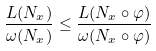Convert formula to latex. <formula><loc_0><loc_0><loc_500><loc_500>\frac { L ( N _ { x } ) } { \omega ( N _ { x } ) } \leq \frac { L ( N _ { x } \circ \varphi ) } { \omega ( N _ { x } \circ \varphi ) }</formula> 